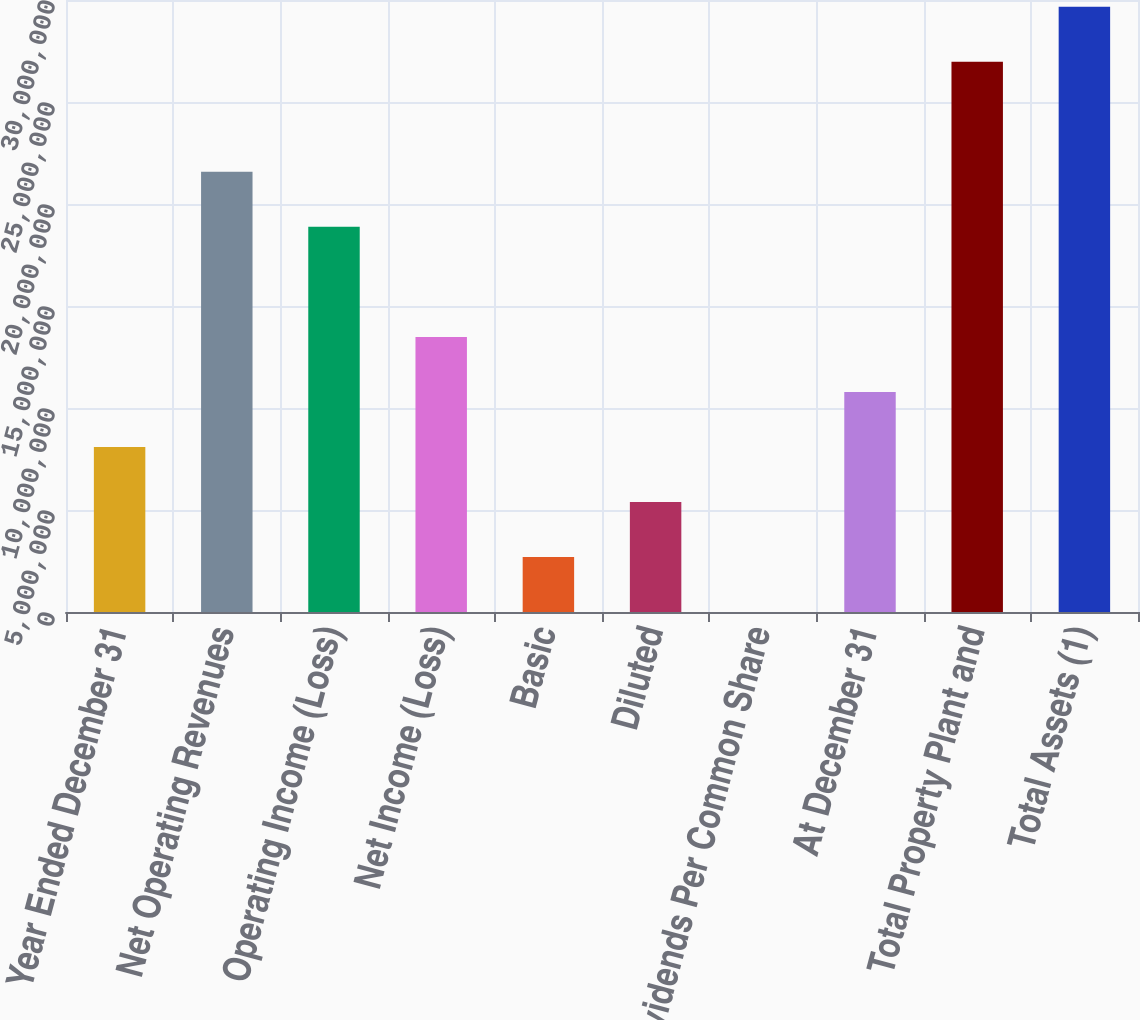Convert chart. <chart><loc_0><loc_0><loc_500><loc_500><bar_chart><fcel>Year Ended December 31<fcel>Net Operating Revenues<fcel>Operating Income (Loss)<fcel>Net Income (Loss)<fcel>Basic<fcel>Diluted<fcel>Dividends Per Common Share<fcel>At December 31<fcel>Total Property Plant and<fcel>Total Assets (1)<nl><fcel>8.09114e+06<fcel>2.15764e+07<fcel>1.88793e+07<fcel>1.34852e+07<fcel>2.69705e+06<fcel>5.39409e+06<fcel>0.67<fcel>1.07882e+07<fcel>2.69705e+07<fcel>2.96675e+07<nl></chart> 